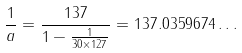<formula> <loc_0><loc_0><loc_500><loc_500>\frac { 1 } { a } = \frac { 1 3 7 } { 1 - \frac { 1 } { 3 0 \times 1 2 7 } } = 1 3 7 . 0 3 5 9 6 7 4 \dots</formula> 